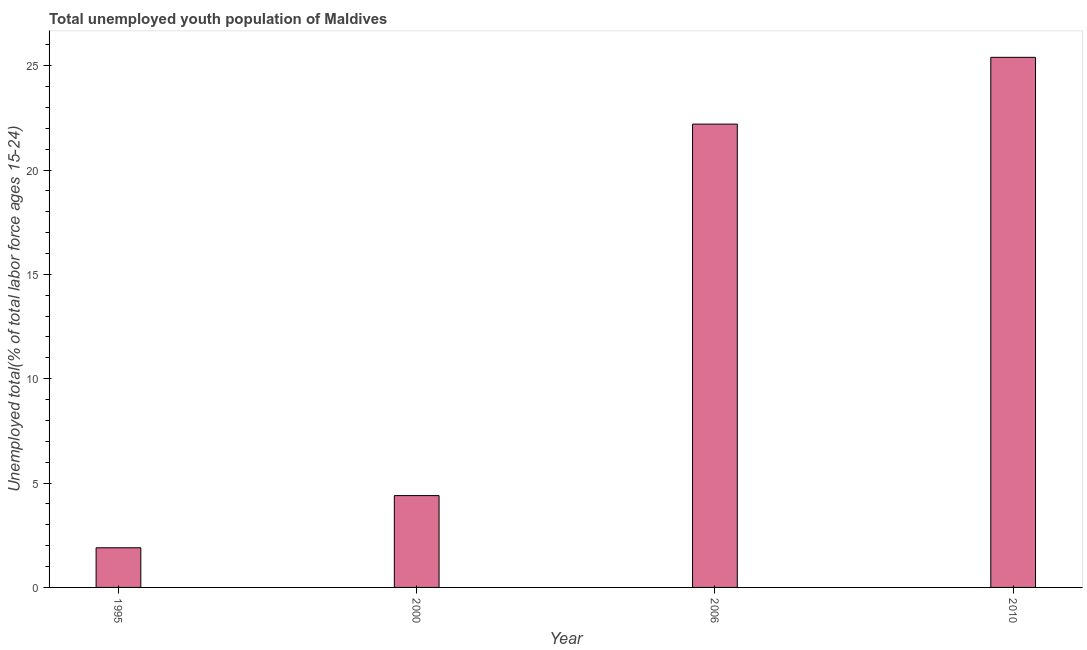Does the graph contain any zero values?
Your answer should be very brief. No. What is the title of the graph?
Provide a short and direct response. Total unemployed youth population of Maldives. What is the label or title of the Y-axis?
Give a very brief answer. Unemployed total(% of total labor force ages 15-24). What is the unemployed youth in 2010?
Provide a short and direct response. 25.4. Across all years, what is the maximum unemployed youth?
Give a very brief answer. 25.4. Across all years, what is the minimum unemployed youth?
Make the answer very short. 1.9. In which year was the unemployed youth maximum?
Ensure brevity in your answer.  2010. What is the sum of the unemployed youth?
Ensure brevity in your answer.  53.9. What is the difference between the unemployed youth in 1995 and 2006?
Your answer should be compact. -20.3. What is the average unemployed youth per year?
Offer a very short reply. 13.47. What is the median unemployed youth?
Your answer should be very brief. 13.3. In how many years, is the unemployed youth greater than 11 %?
Keep it short and to the point. 2. What is the ratio of the unemployed youth in 2000 to that in 2006?
Give a very brief answer. 0.2. Is the unemployed youth in 2000 less than that in 2010?
Your answer should be very brief. Yes. What is the difference between the highest and the lowest unemployed youth?
Provide a short and direct response. 23.5. In how many years, is the unemployed youth greater than the average unemployed youth taken over all years?
Your answer should be compact. 2. How many bars are there?
Offer a terse response. 4. What is the Unemployed total(% of total labor force ages 15-24) in 1995?
Your answer should be compact. 1.9. What is the Unemployed total(% of total labor force ages 15-24) in 2000?
Offer a terse response. 4.4. What is the Unemployed total(% of total labor force ages 15-24) of 2006?
Provide a succinct answer. 22.2. What is the Unemployed total(% of total labor force ages 15-24) of 2010?
Your answer should be compact. 25.4. What is the difference between the Unemployed total(% of total labor force ages 15-24) in 1995 and 2000?
Offer a terse response. -2.5. What is the difference between the Unemployed total(% of total labor force ages 15-24) in 1995 and 2006?
Make the answer very short. -20.3. What is the difference between the Unemployed total(% of total labor force ages 15-24) in 1995 and 2010?
Provide a short and direct response. -23.5. What is the difference between the Unemployed total(% of total labor force ages 15-24) in 2000 and 2006?
Ensure brevity in your answer.  -17.8. What is the difference between the Unemployed total(% of total labor force ages 15-24) in 2000 and 2010?
Your response must be concise. -21. What is the difference between the Unemployed total(% of total labor force ages 15-24) in 2006 and 2010?
Ensure brevity in your answer.  -3.2. What is the ratio of the Unemployed total(% of total labor force ages 15-24) in 1995 to that in 2000?
Provide a succinct answer. 0.43. What is the ratio of the Unemployed total(% of total labor force ages 15-24) in 1995 to that in 2006?
Offer a terse response. 0.09. What is the ratio of the Unemployed total(% of total labor force ages 15-24) in 1995 to that in 2010?
Keep it short and to the point. 0.07. What is the ratio of the Unemployed total(% of total labor force ages 15-24) in 2000 to that in 2006?
Offer a terse response. 0.2. What is the ratio of the Unemployed total(% of total labor force ages 15-24) in 2000 to that in 2010?
Offer a very short reply. 0.17. What is the ratio of the Unemployed total(% of total labor force ages 15-24) in 2006 to that in 2010?
Your answer should be very brief. 0.87. 